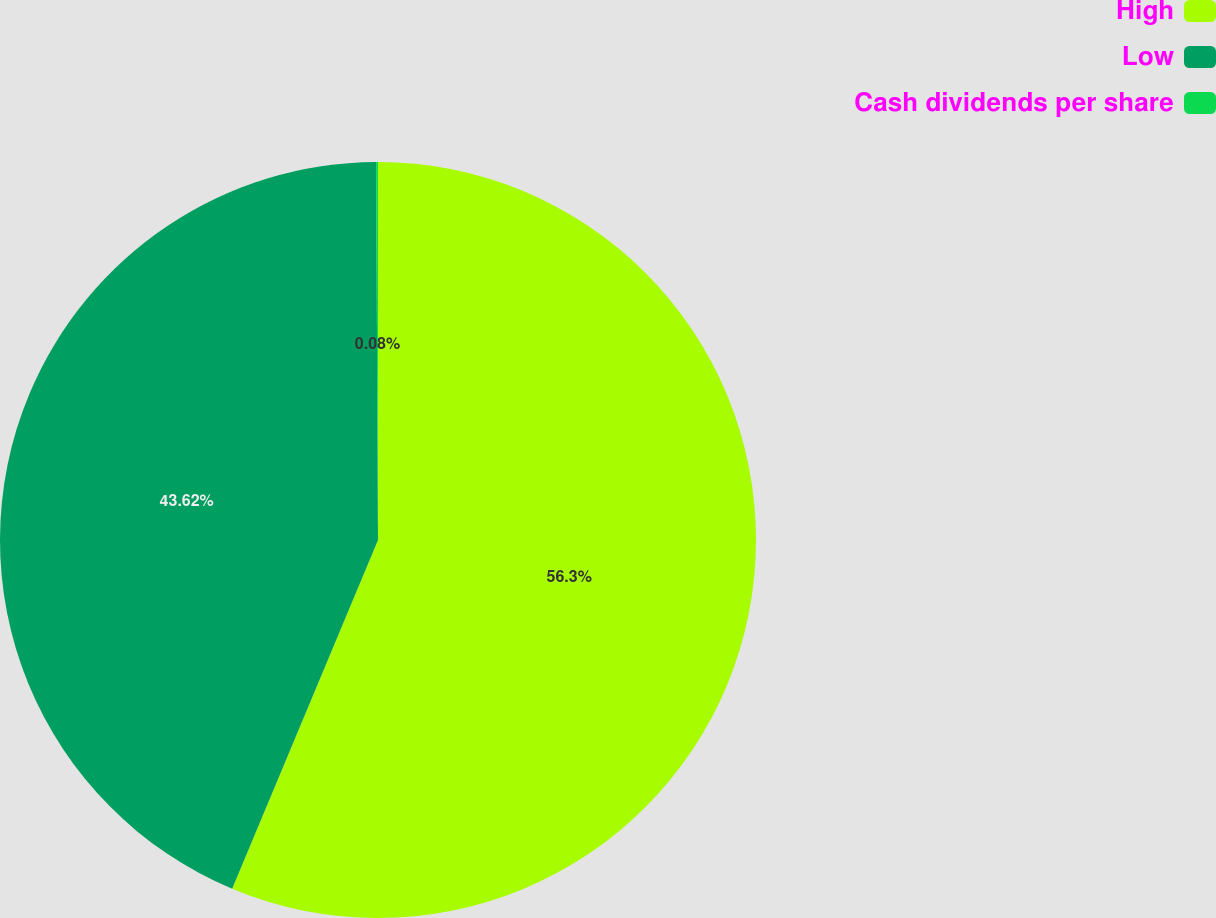Convert chart. <chart><loc_0><loc_0><loc_500><loc_500><pie_chart><fcel>High<fcel>Low<fcel>Cash dividends per share<nl><fcel>56.31%<fcel>43.62%<fcel>0.08%<nl></chart> 